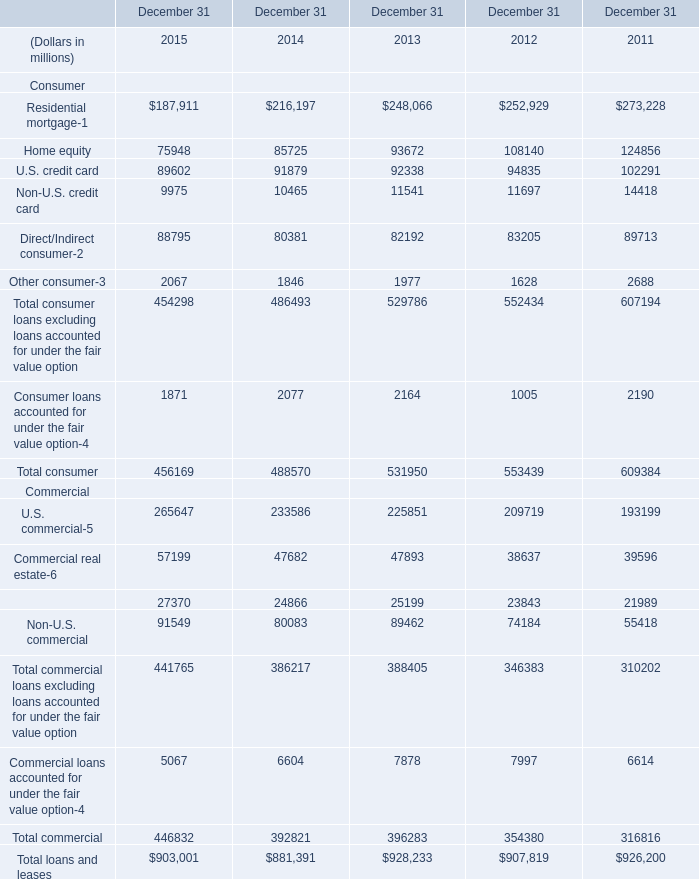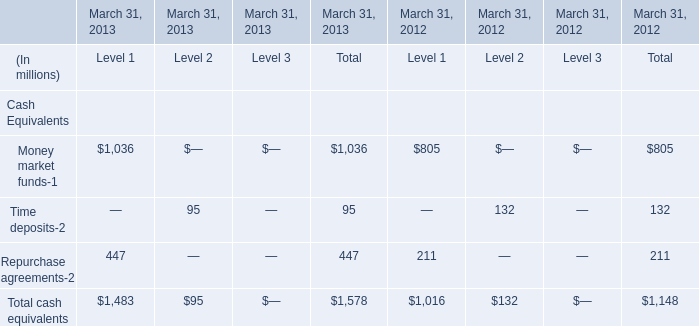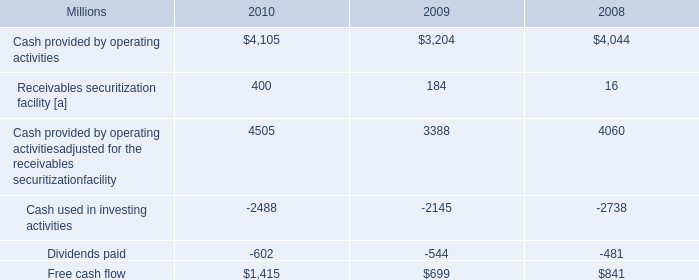What's the average of Total consumer in2013,2014 and 2015? (in million) 
Computations: (((456169 + 488570) + 531950) / 3)
Answer: 492229.66667. 